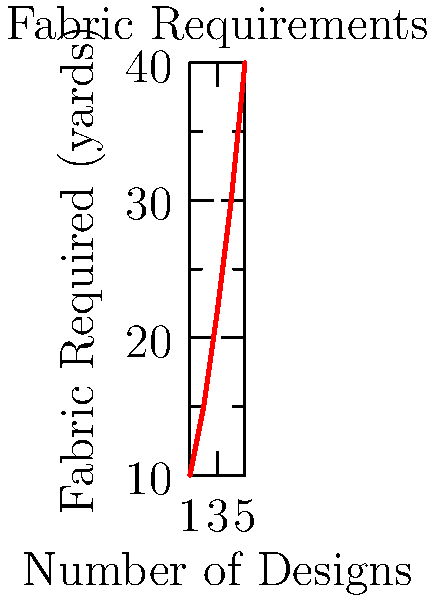You're designing a politically-themed fashion collection with protest slogans. The graph shows the relationship between the number of designs and the total fabric required. If you need to create 7 designs, how many yards of fabric will you need based on the trend shown? To solve this problem, we need to:

1. Observe the trend in the graph: As the number of designs increases, the fabric required increases non-linearly.

2. Find the pattern: The fabric requirement seems to follow a quadratic growth pattern.

3. Calculate the rate of change:
   From 1 to 2 designs: increase of 5 yards
   From 2 to 3 designs: increase of 7 yards
   From 3 to 4 designs: increase of 8 yards
   From 4 to 5 designs: increase of 10 yards

4. Extrapolate the pattern:
   For 6 designs: approximately 40 + 12 = 52 yards
   For 7 designs: approximately 52 + 14 = 66 yards

5. Round to the nearest whole number: 66 yards

This estimation assumes the quadratic growth continues beyond the given data points.
Answer: 66 yards 